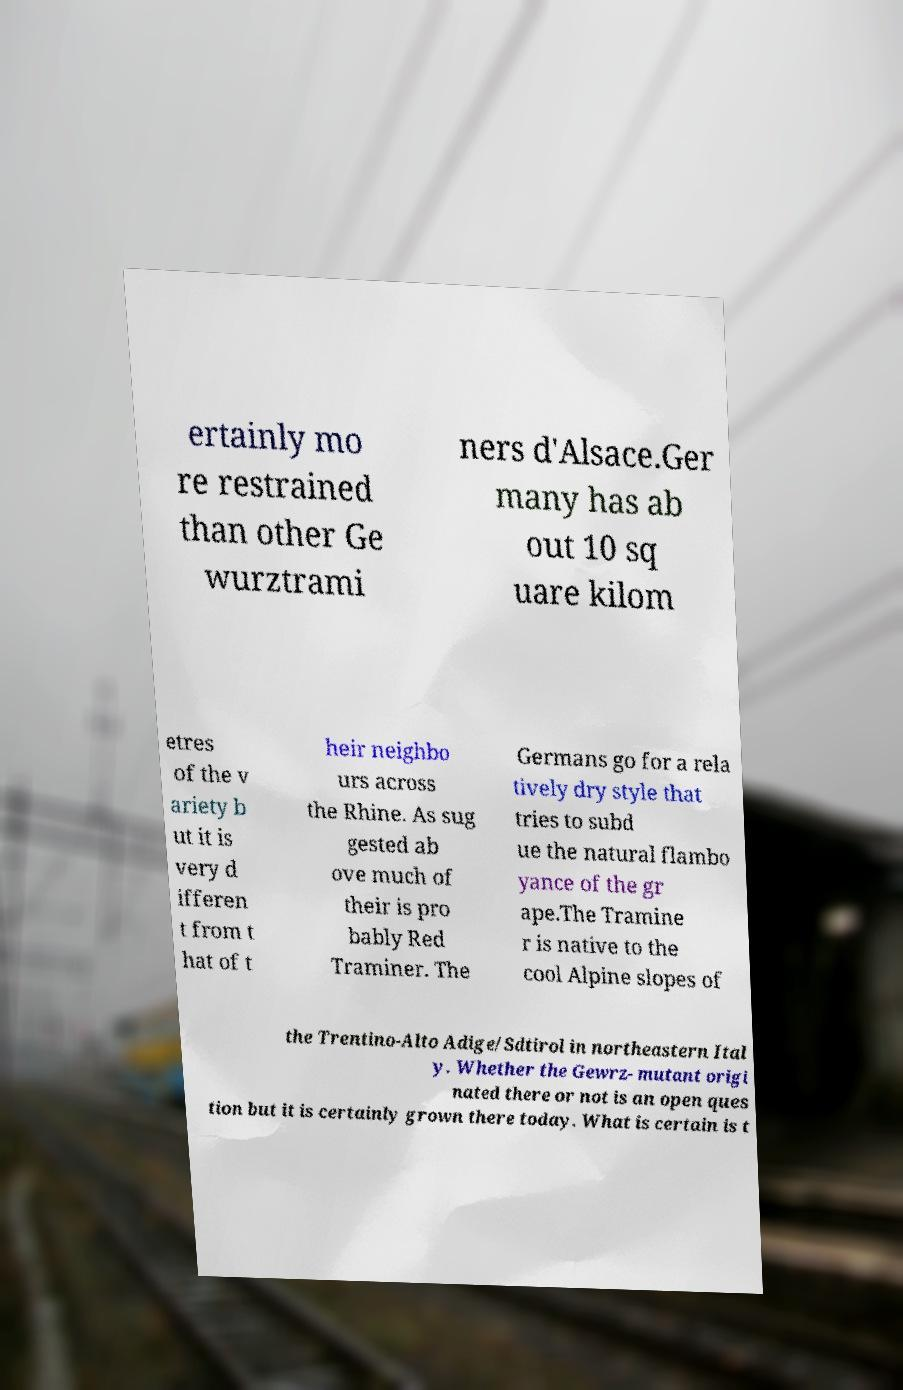I need the written content from this picture converted into text. Can you do that? ertainly mo re restrained than other Ge wurztrami ners d'Alsace.Ger many has ab out 10 sq uare kilom etres of the v ariety b ut it is very d ifferen t from t hat of t heir neighbo urs across the Rhine. As sug gested ab ove much of their is pro bably Red Traminer. The Germans go for a rela tively dry style that tries to subd ue the natural flambo yance of the gr ape.The Tramine r is native to the cool Alpine slopes of the Trentino-Alto Adige/Sdtirol in northeastern Ital y. Whether the Gewrz- mutant origi nated there or not is an open ques tion but it is certainly grown there today. What is certain is t 